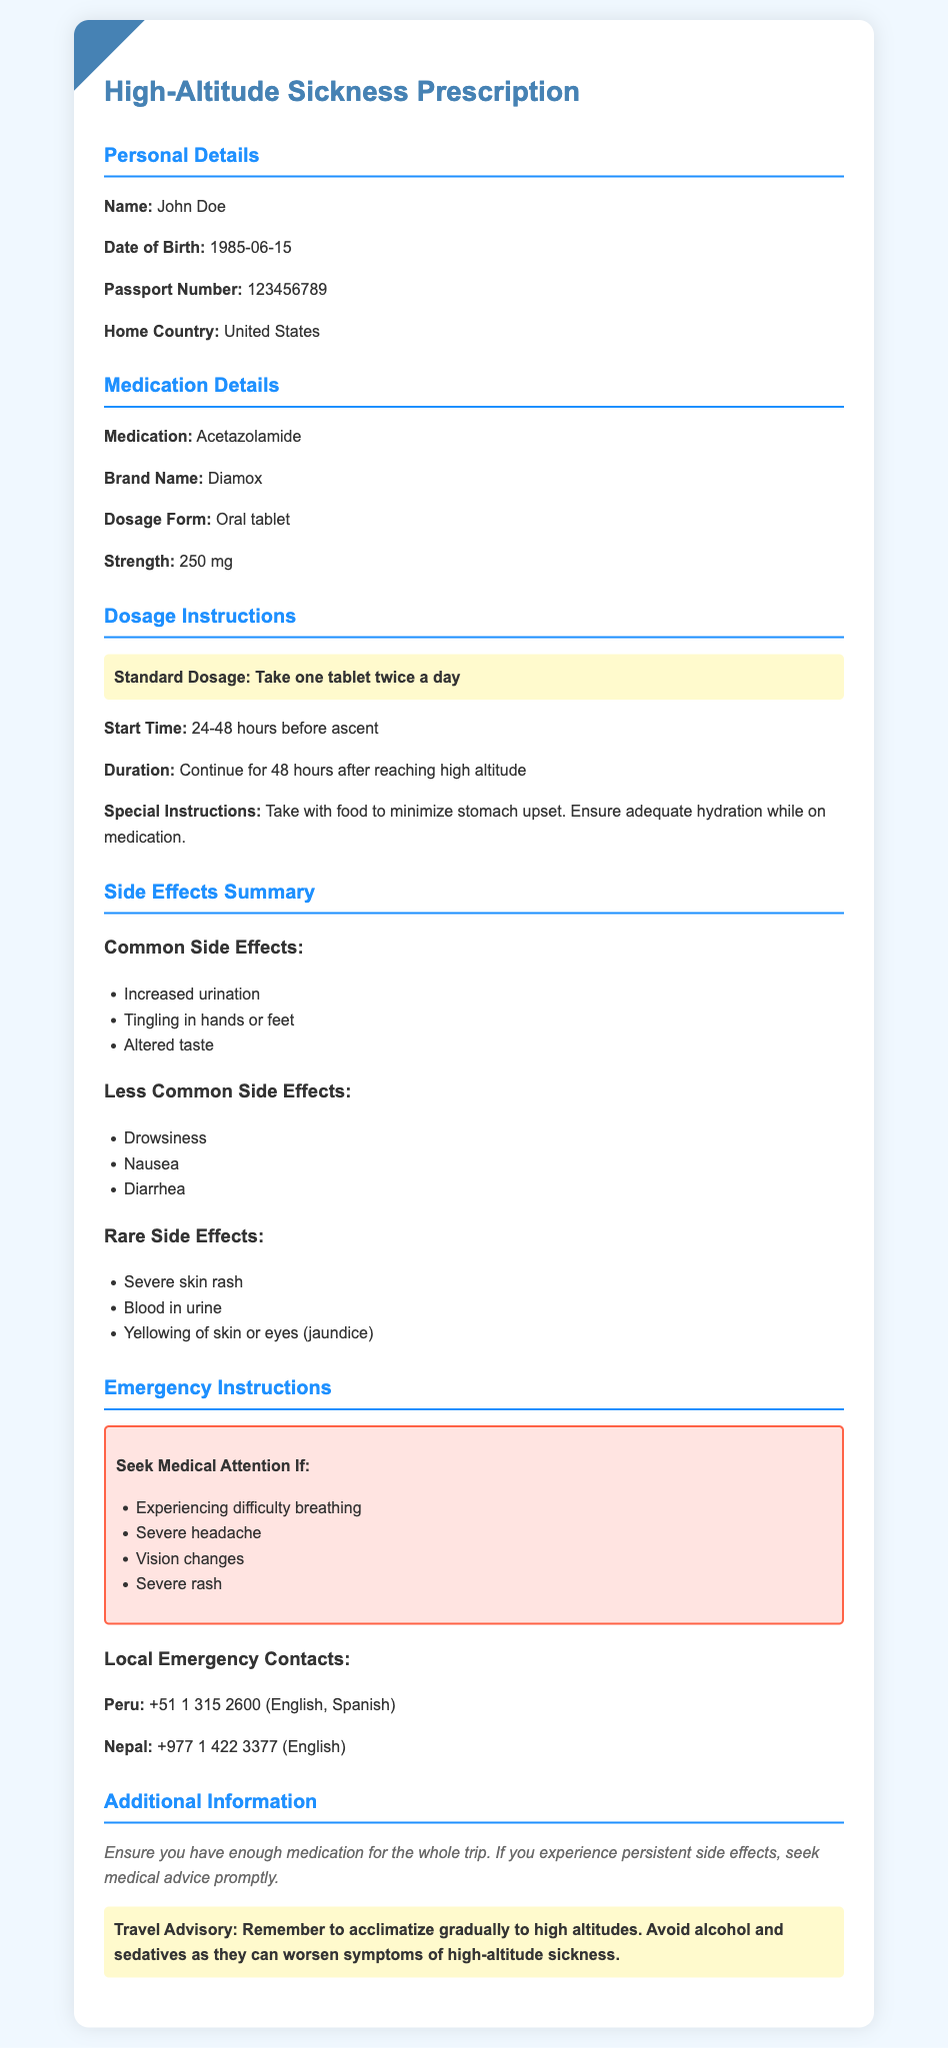what is the medication prescribed? The medication prescribed is clearly stated in the document under the medication details section.
Answer: Acetazolamide what is the brand name of the medication? The brand name is mentioned alongside the medication in the prescription details.
Answer: Diamox what is the standard dosage of the medication? The standard dosage is highlighted in the dosage instructions section as a specific instruction.
Answer: Take one tablet twice a day how long before ascent should the medication be started? The document specifies the start time in the dosage instructions, providing a clear timeline.
Answer: 24-48 hours what are the common side effects listed? The common side effects are detailed in the side effects summary section of the document.
Answer: Increased urination, Tingling in hands or feet, Altered taste what should you do if experiencing difficulty breathing? The emergency instructions provide guidance on what to do in case of specific symptoms.
Answer: Seek Medical Attention what is the contact number for emergency medical services in Peru? The local emergency contacts for Peru are listed under the emergency instructions.
Answer: +51 1 315 2600 how long should the medication be continued after reaching high altitude? The duration is mentioned in the dosage instructions, indicating the length of time for continued use.
Answer: 48 hours what important travel advisory is mentioned? The additional information section highlights important travel advice relevant to altitude acclimatization.
Answer: Acclimatize gradually to high altitudes 